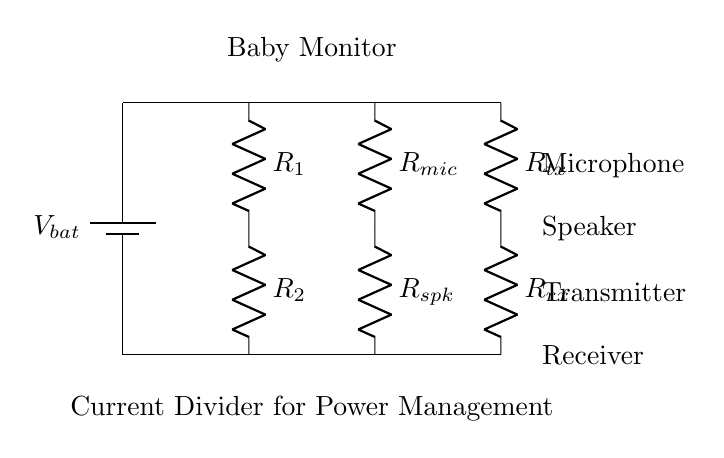What is the total resistance in the current divider? The total resistance in the current divider can be calculated using the formula for resistors in parallel, which is 1/R_total = 1/R1 + 1/R2. Here, R1 and R2 represent the resistances of the two main resistors.
Answer: R_total What specific role does the microphone play in this circuit? The microphone is represented by the resistor labeled R_mic, which plays a crucial role in converting sound energy into electrical signals. It receives power and transmits audio signals to the speaker and transmitter.
Answer: Audio transmission What current splitting occurs at the junction after R1 and R2? At the junction after R1 and R2, current splits between R_mic and R_spk, depending on their resistances as per the current divider rule, where the current through each branch is inversely proportional to its resistance.
Answer: Current division Which resistors contribute to the power management feature? R1 and R2 contribute to the power management feature as they form a current divider that helps distribute power efficiently to the downstream components like the microphone and speaker, aiding in extended battery life.
Answer: R1 and R2 How does the circuit ensure extended battery life? The circuit employs parallel resistors to manage power distribution, allowing lower power draw and efficient use of battery resources, resulting in extended battery life for the baby monitor.
Answer: Efficient power distribution 